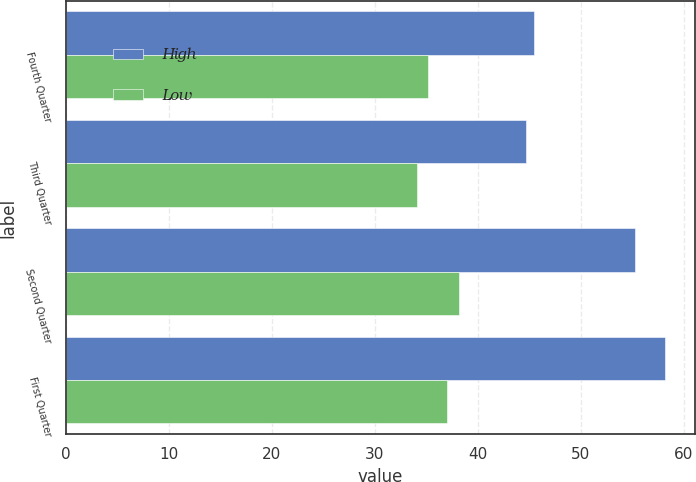Convert chart. <chart><loc_0><loc_0><loc_500><loc_500><stacked_bar_chart><ecel><fcel>Fourth Quarter<fcel>Third Quarter<fcel>Second Quarter<fcel>First Quarter<nl><fcel>High<fcel>45.5<fcel>44.7<fcel>55.25<fcel>58.19<nl><fcel>Low<fcel>35.21<fcel>34.16<fcel>38.17<fcel>37.01<nl></chart> 